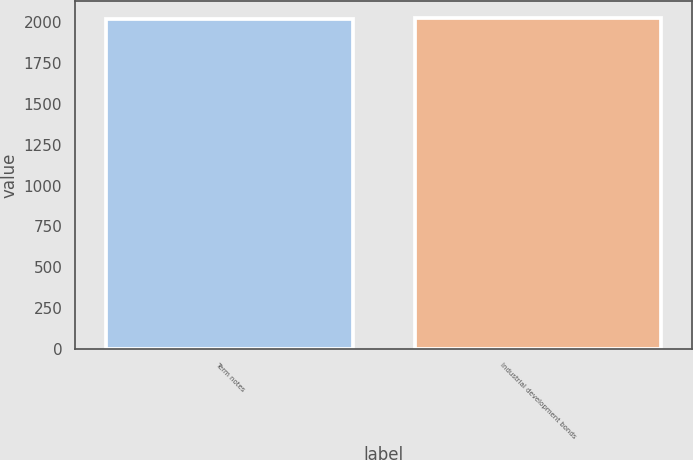Convert chart to OTSL. <chart><loc_0><loc_0><loc_500><loc_500><bar_chart><fcel>Term notes<fcel>Industrial development bonds<nl><fcel>2022<fcel>2030<nl></chart> 